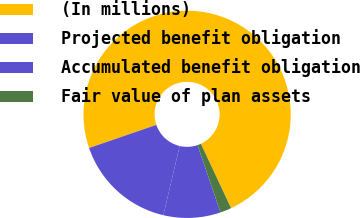Convert chart to OTSL. <chart><loc_0><loc_0><loc_500><loc_500><pie_chart><fcel>(In millions)<fcel>Projected benefit obligation<fcel>Accumulated benefit obligation<fcel>Fair value of plan assets<nl><fcel>73.29%<fcel>16.06%<fcel>8.9%<fcel>1.75%<nl></chart> 